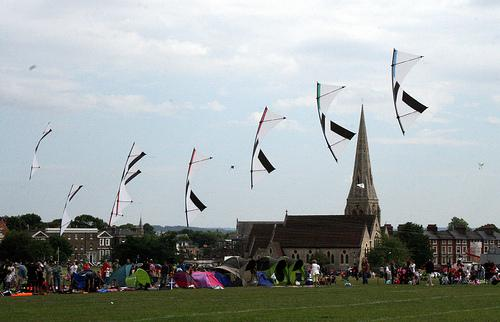Question: why are people outside?
Choices:
A. Concert.
B. Picnic.
C. At the park.
D. It's a celebration.
Answer with the letter. Answer: D Question: how many kites are in the air?
Choices:
A. 8.
B. 9.
C. 5.
D. 7.
Answer with the letter. Answer: D Question: where are the kites?
Choices:
A. Beach.
B. In the air.
C. Park.
D. Outside.
Answer with the letter. Answer: B Question: what color are the kites?
Choices:
A. Blue.
B. Yellow.
C. Orange.
D. Black and white.
Answer with the letter. Answer: D 